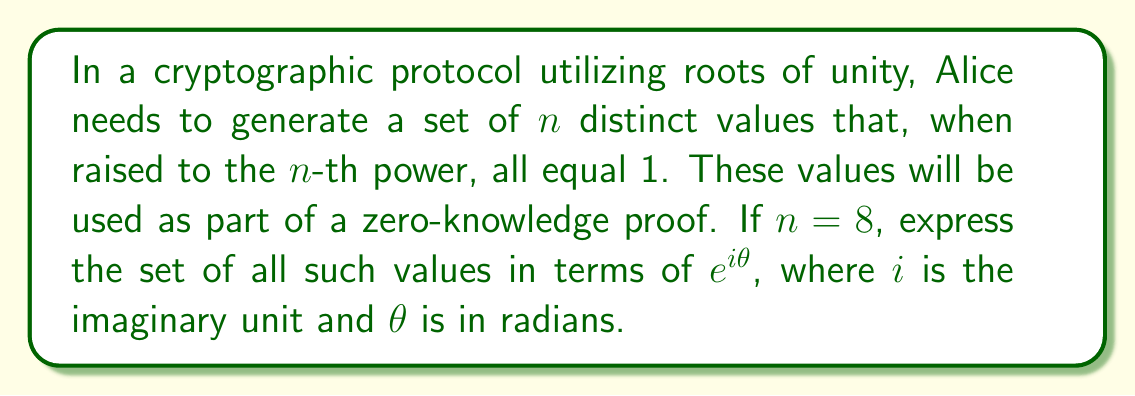Show me your answer to this math problem. Let's approach this step-by-step:

1) The roots of unity are complex numbers that, when raised to some power $n$, equal 1. They are given by the formula:

   $$\omega_k = e^{2\pi i k / n}$$

   where $k = 0, 1, 2, ..., n-1$

2) In this case, $n = 8$, so we need to find all values of $\omega_k$ where:

   $$\omega_k = e^{2\pi i k / 8}$$

3) Let's calculate each value:

   For $k = 0$: $\omega_0 = e^{2\pi i \cdot 0 / 8} = e^{0} = 1$
   For $k = 1$: $\omega_1 = e^{2\pi i \cdot 1 / 8} = e^{\pi i / 4}$
   For $k = 2$: $\omega_2 = e^{2\pi i \cdot 2 / 8} = e^{\pi i / 2}$
   For $k = 3$: $\omega_3 = e^{2\pi i \cdot 3 / 8} = e^{3\pi i / 4}$
   For $k = 4$: $\omega_4 = e^{2\pi i \cdot 4 / 8} = e^{\pi i} = -1$
   For $k = 5$: $\omega_5 = e^{2\pi i \cdot 5 / 8} = e^{5\pi i / 4}$
   For $k = 6$: $\omega_6 = e^{2\pi i \cdot 6 / 8} = e^{3\pi i / 2}$
   For $k = 7$: $\omega_7 = e^{2\pi i \cdot 7 / 8} = e^{7\pi i / 4}$

4) These 8 values form the complete set of 8th roots of unity.
Answer: $\{1, e^{\pi i / 4}, e^{\pi i / 2}, e^{3\pi i / 4}, -1, e^{5\pi i / 4}, e^{3\pi i / 2}, e^{7\pi i / 4}\}$ 